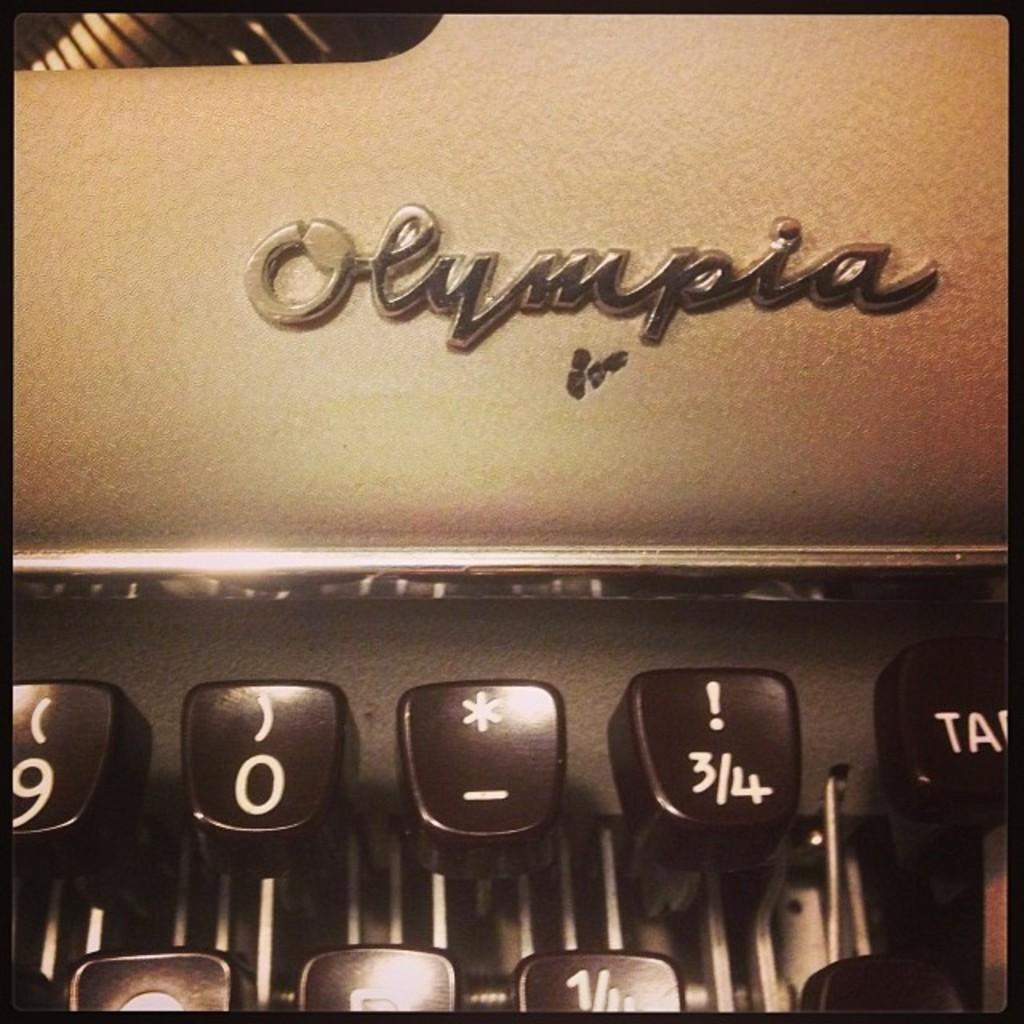<image>
Share a concise interpretation of the image provided. a typewriter with five black buttons and the words olympia in script 